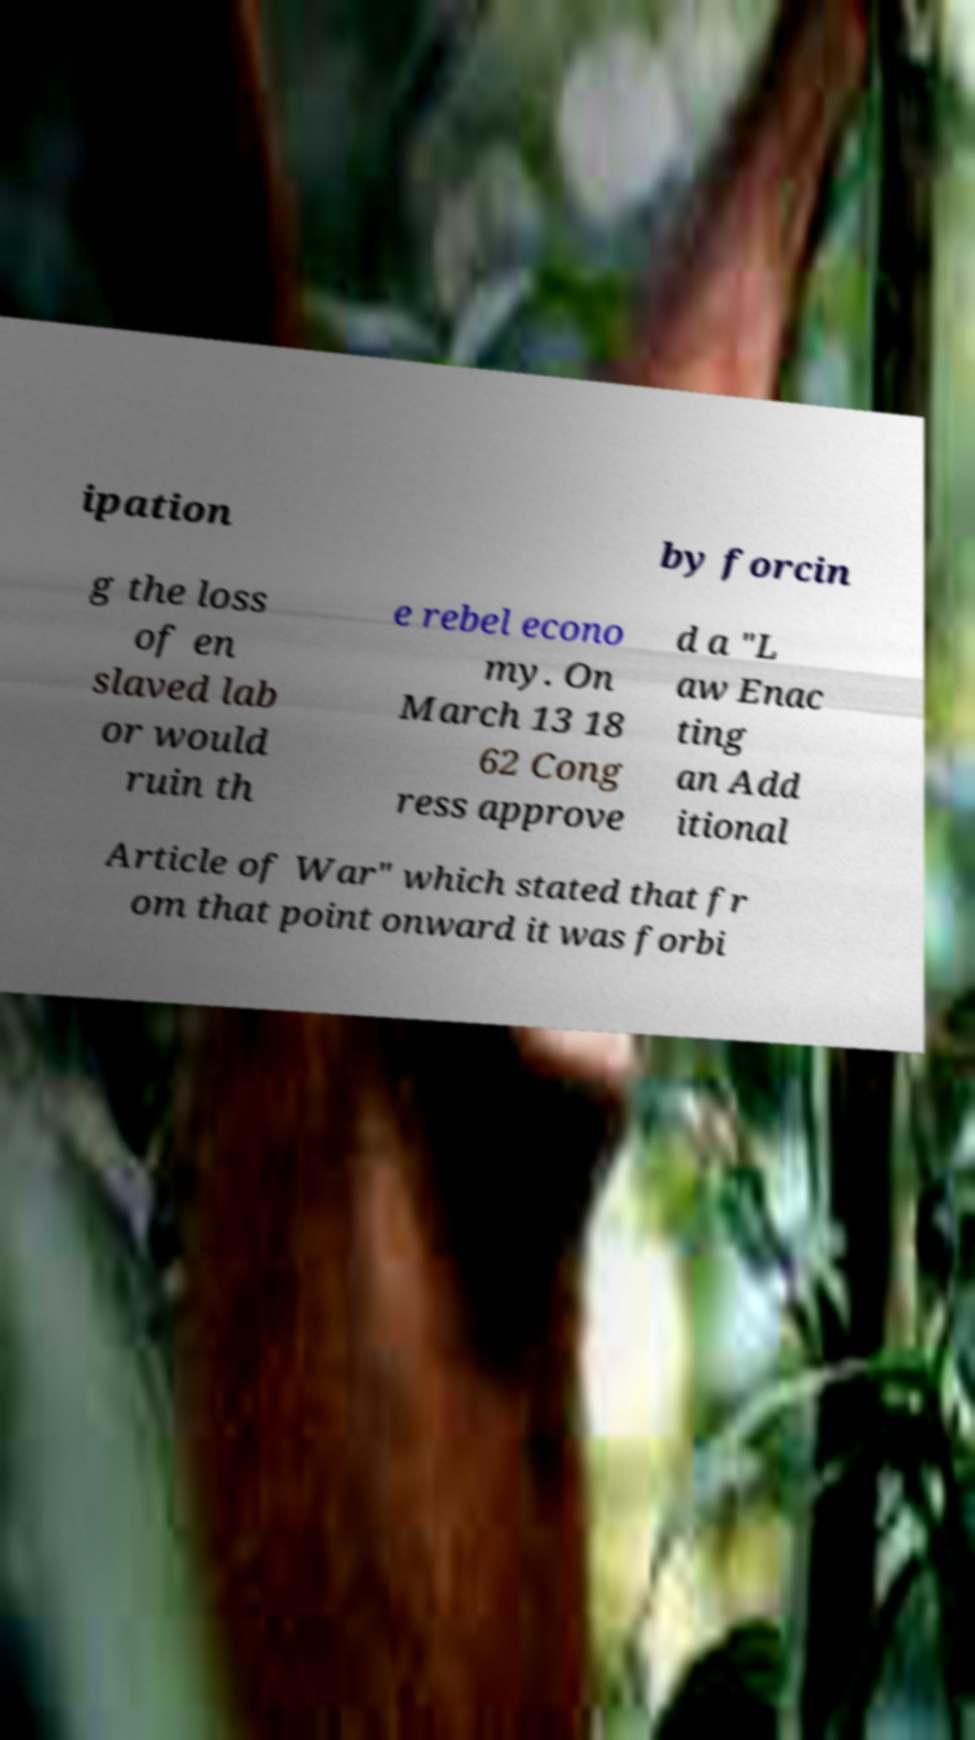For documentation purposes, I need the text within this image transcribed. Could you provide that? ipation by forcin g the loss of en slaved lab or would ruin th e rebel econo my. On March 13 18 62 Cong ress approve d a "L aw Enac ting an Add itional Article of War" which stated that fr om that point onward it was forbi 